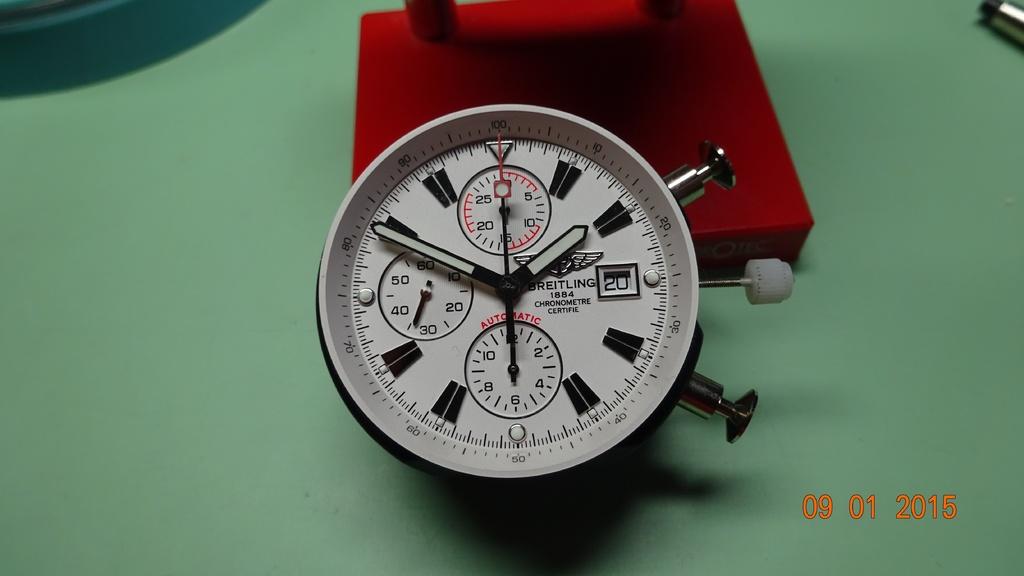What year was the photo taken?
Offer a very short reply. 2015. What year does it say on the watch face?
Keep it short and to the point. 1884. 